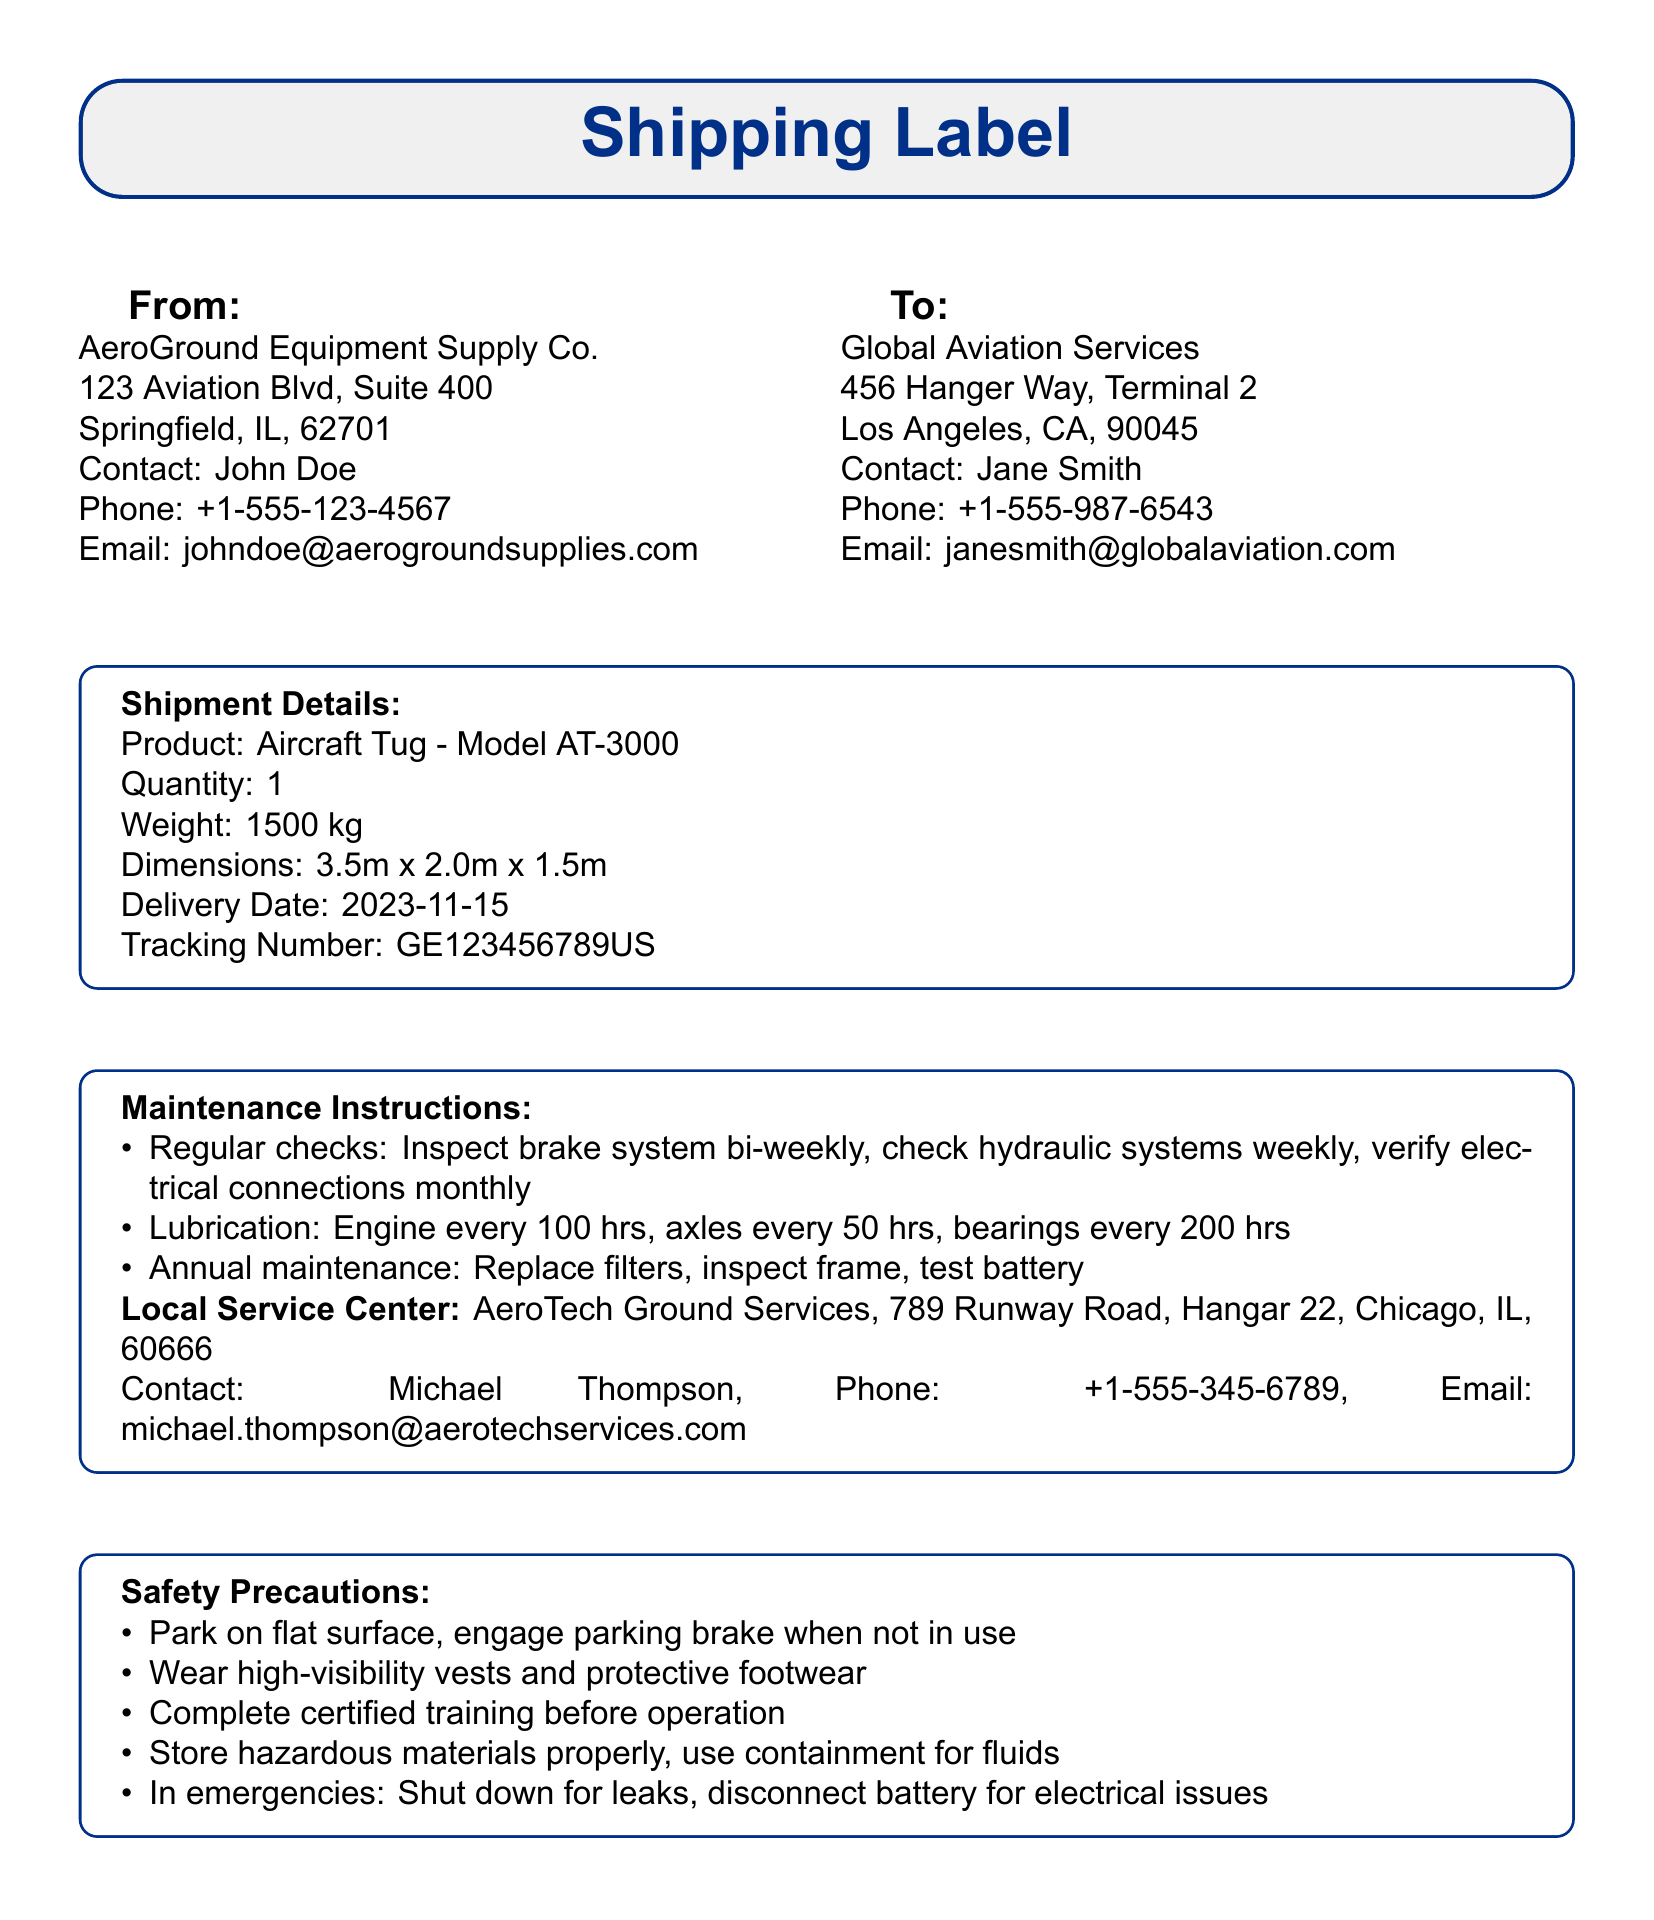What is the product being shipped? The product details indicate that the shipment is for an Aircraft Tug of Model AT-3000.
Answer: Aircraft Tug - Model AT-3000 What is the delivery date? The document specifies that the delivery date is November 15, 2023.
Answer: 2023-11-15 Who is the contact person at the delivery address? The "To" section provides the contact person at the delivery address as Jane Smith.
Answer: Jane Smith What is the weight of the equipment? The shipment details state that the weight of the equipment is 1500 kg.
Answer: 1500 kg What are the safety precautions regarding parking? The safety precautions mention to park on a flat surface and engage the parking brake when not in use.
Answer: Park on flat surface, engage parking brake when not in use What is the contact email for the local service center? The maintenance instructions state the contact email for the local service center is michael.thompson@aerotechservices.com.
Answer: michael.thompson@aerotechservices.com How often should the brake system be inspected? The maintenance instructions recommend inspecting the brake system bi-weekly.
Answer: bi-weekly What is the tracking number for the shipment? The shipment details include the tracking number as GE123456789US.
Answer: GE123456789US What is the contact phone number for the sender? The sender's contact number listed is +1-555-123-4567.
Answer: +1-555-123-4567 